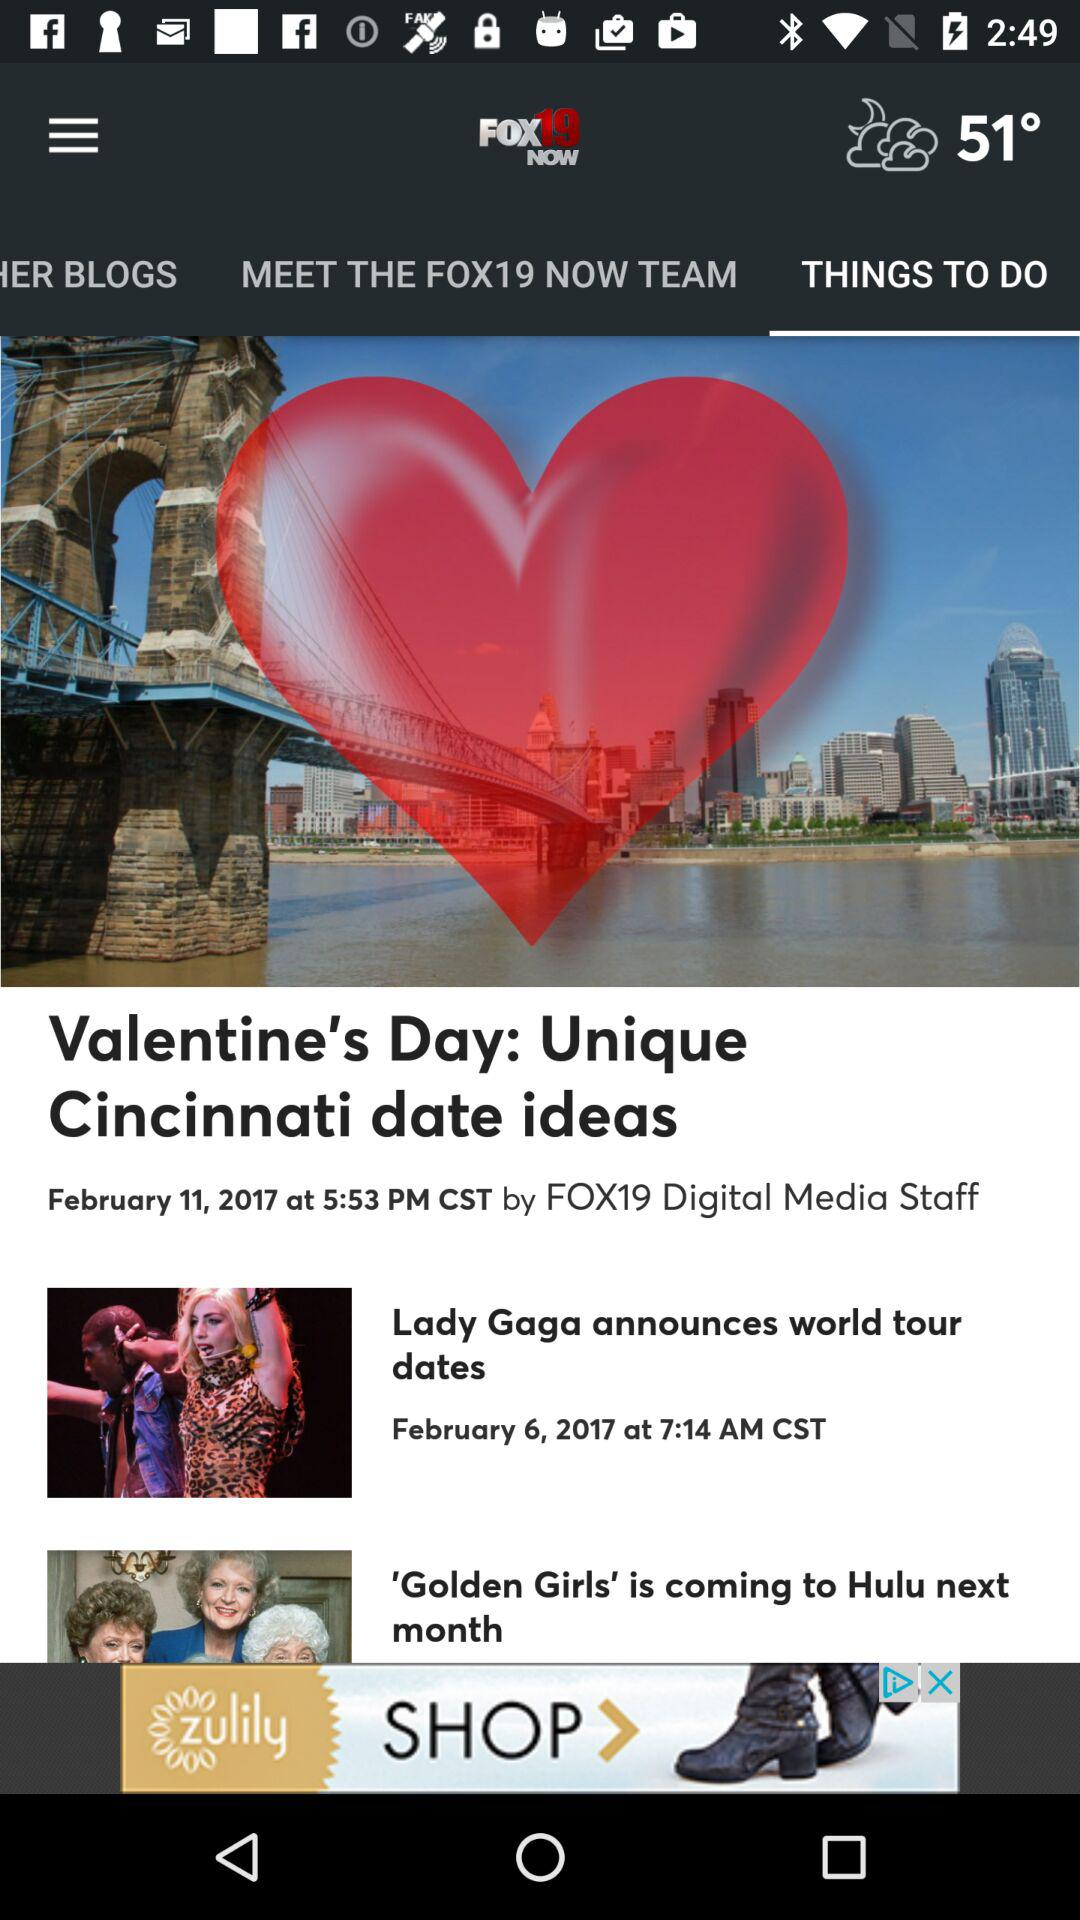How many articles are in "MEET THE FOX19 NOW TEAM"?
When the provided information is insufficient, respond with <no answer>. <no answer> 